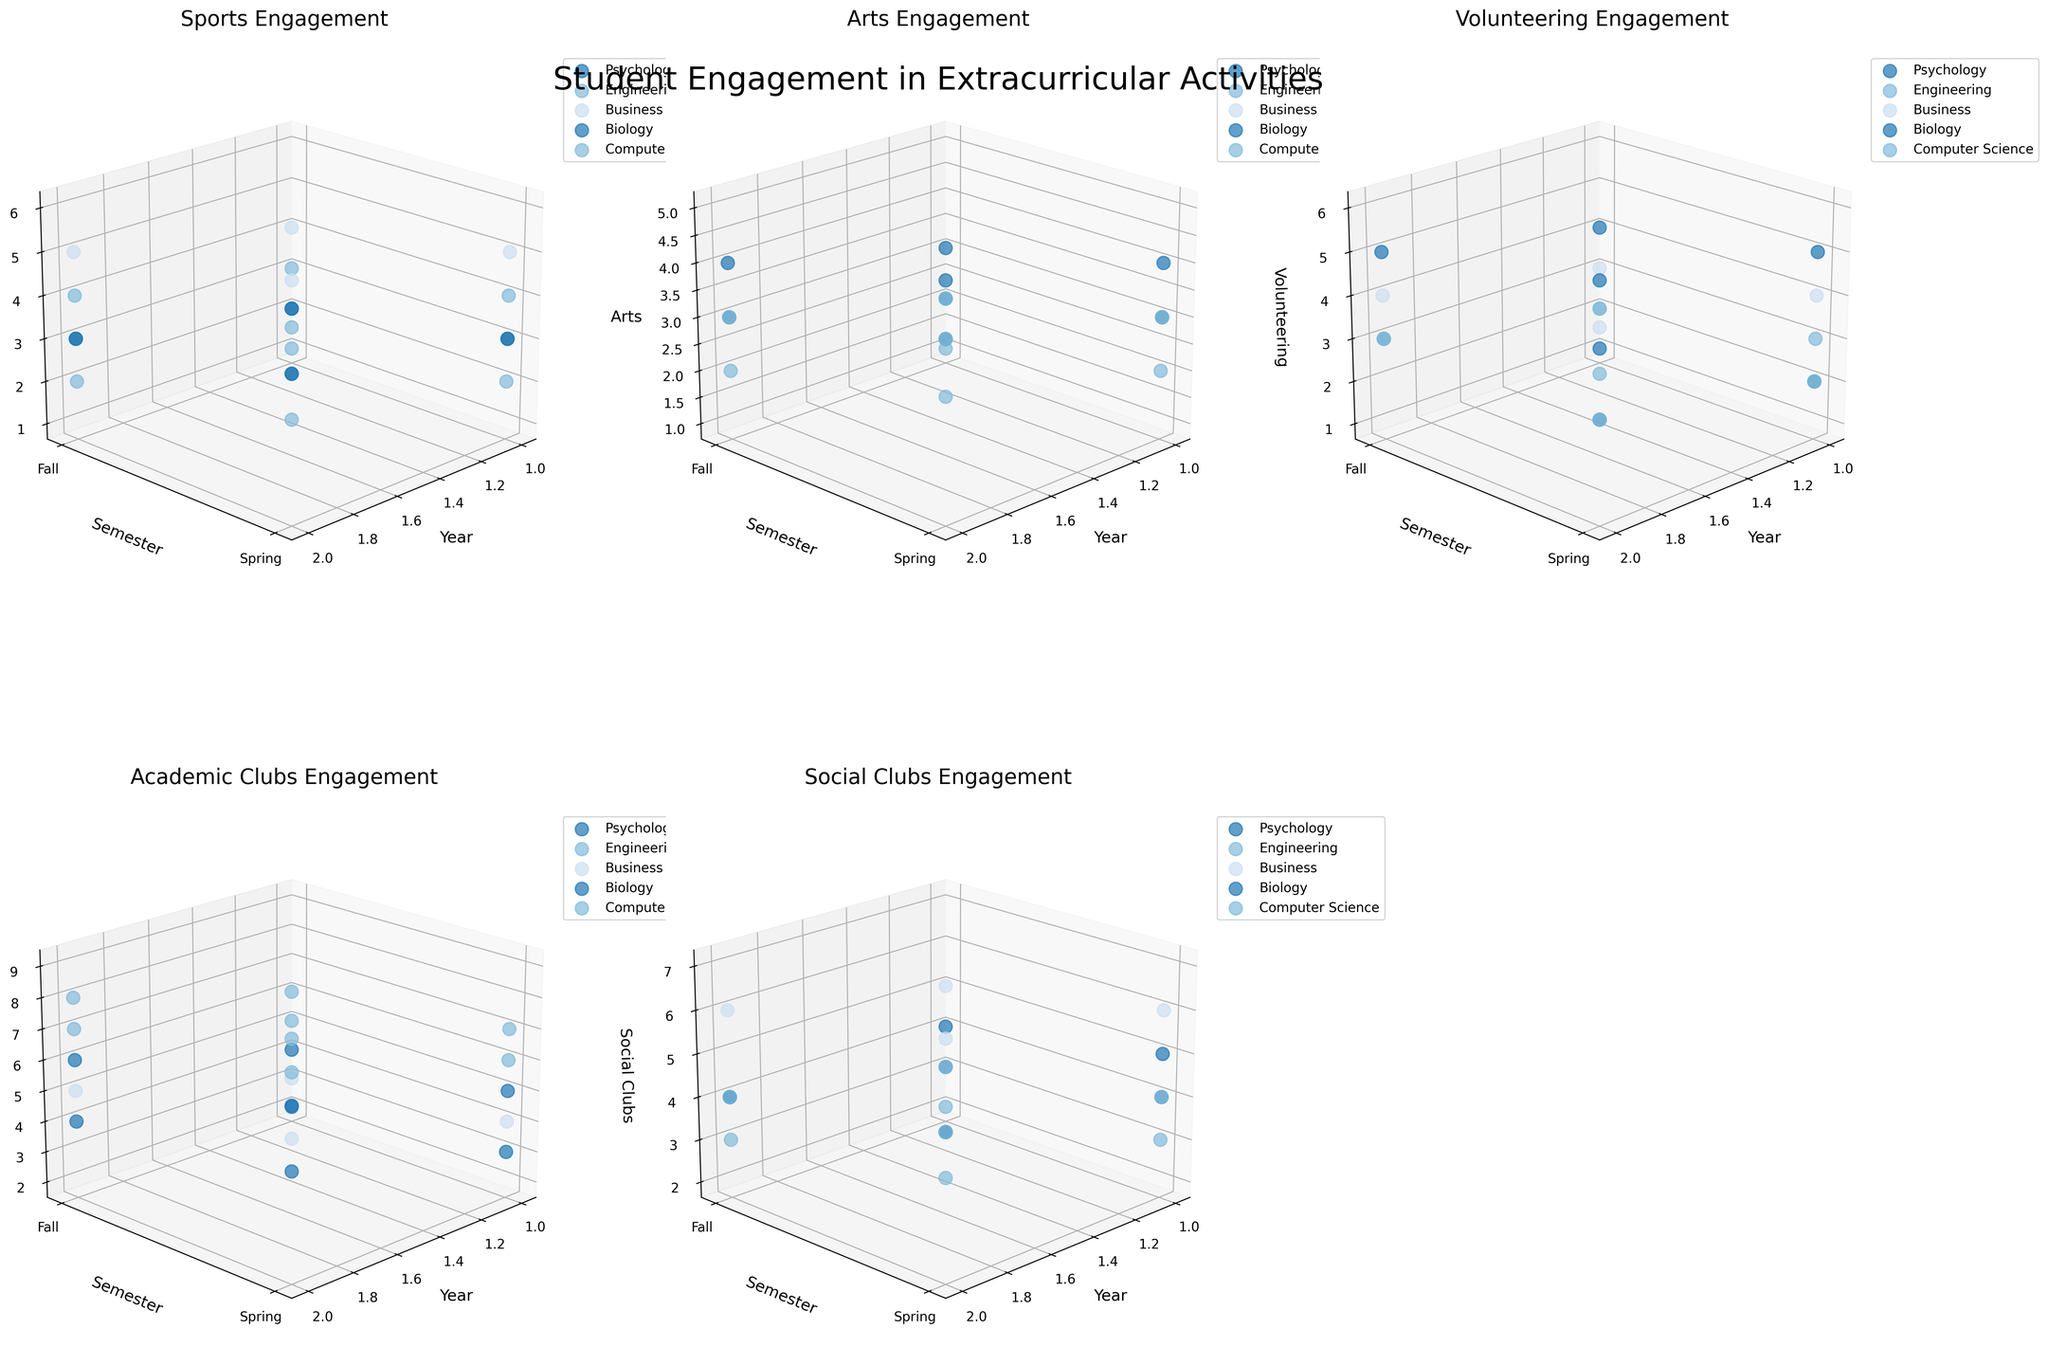What's the 3D plot at the first subplot depicting? The first subplot is depicting the Student Engagement in Sports across different majors, years, and semesters. The x-axis is "Year", y-axis is "Semester", and z-axis is "Sports".
Answer: Engagement in Sports Which major shows the highest engagement in Volunteering during the second year Spring semester? In the subplot for Volunteering Engagement, look for the data points where "Year" is 2 and "Semester" is Spring (y = 1). Among those, the major with the highest "Volunteering" value will be Business, as it reaches a value of 5.
Answer: Business How does engagement in Social Clubs change for Psychology students from first year Fall to second year Spring? For Psychology students, we need to compare the z-values in the Social Clubs subplot from first-year Fall (Year = 1, Semester = Fall, z = 4) to second-year Spring (Year = 2, Semester = Spring, z = 5). The engagement increases by 1 from 4 to 5.
Answer: Increases by 1 For which activity do Computer Science students show the highest engagement in the first year Spring semester? Check the subplot for each activity and locate data points where "Major" is Computer Science, "Year" is 1, and "Semester" is Spring. The highest z-value for this set of points appears in "Academic Clubs" with a value of 7.
Answer: Academic Clubs What trend do you observe in engagement in Academic Clubs across years for Engineering students? In the subplot for Academic Clubs, observe the pattern of z-values for Engineering students from Year 1 through Year 2. The z-values increase from 5 (Year 1, Fall) to 6 (Year 1, Spring), then to 7 (Year 2, Fall), and finally to 8 (Year 2, Spring). This shows a steady upward trend.
Answer: Steady increase Do students generally have higher engagement in Arts during the Spring or the Fall semester? Observe the Arts subplot and compare the general height of data points (z-values) for Fall and Spring semesters across all majors. Spring semester shows generally higher z-values compared to Fall semester, indicating higher engagement in Spring.
Answer: Spring Which major has the lowest Sports engagement in both first and second year Fall semesters? In the subplot for Sports Engagement, locate the data points for Fall semesters and compare across majors. Computer Science has the lowest z-values (1 in Year 1 and 2 in Year 2) for Fall semesters.
Answer: Computer Science Is there any major where engagement in Volunteering remains constant from first to second year? For Volunteering Engagement subplot, check if any major has the same z-values across Year 1 and Year 2. Engineering students have a consistent engagement of 2 in Year 1 and Year 2 Fall semesters.
Answer: Engineering Which activity shows the most variation in engagement across all majors, years, and semesters? By visually comparing the spread and range of z-values across all 3D subplots, "Academic Clubs" shows the most variation, ranging from 2 up to 9, indicating high variations among years, semesters, and majors.
Answer: Academic Clubs 